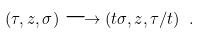<formula> <loc_0><loc_0><loc_500><loc_500>( \tau , z , \sigma ) \longrightarrow ( t \sigma , z , \tau / t ) \ .</formula> 